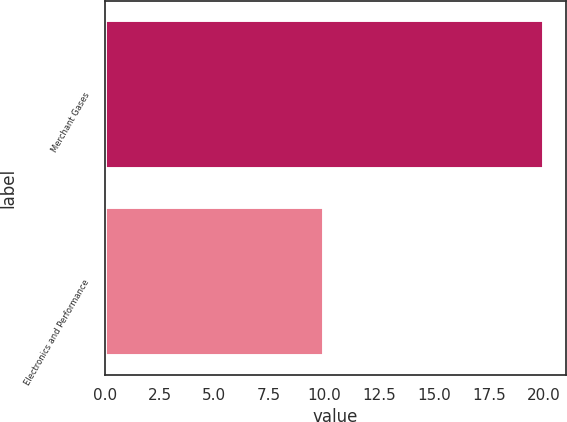Convert chart. <chart><loc_0><loc_0><loc_500><loc_500><bar_chart><fcel>Merchant Gases<fcel>Electronics and Performance<nl><fcel>20<fcel>10<nl></chart> 